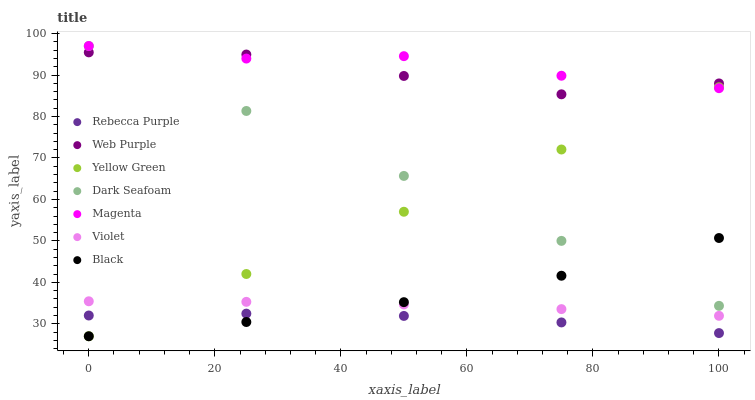Does Rebecca Purple have the minimum area under the curve?
Answer yes or no. Yes. Does Magenta have the maximum area under the curve?
Answer yes or no. Yes. Does Dark Seafoam have the minimum area under the curve?
Answer yes or no. No. Does Dark Seafoam have the maximum area under the curve?
Answer yes or no. No. Is Dark Seafoam the smoothest?
Answer yes or no. Yes. Is Web Purple the roughest?
Answer yes or no. Yes. Is Web Purple the smoothest?
Answer yes or no. No. Is Dark Seafoam the roughest?
Answer yes or no. No. Does Yellow Green have the lowest value?
Answer yes or no. Yes. Does Dark Seafoam have the lowest value?
Answer yes or no. No. Does Magenta have the highest value?
Answer yes or no. Yes. Does Web Purple have the highest value?
Answer yes or no. No. Is Violet less than Magenta?
Answer yes or no. Yes. Is Magenta greater than Black?
Answer yes or no. Yes. Does Dark Seafoam intersect Magenta?
Answer yes or no. Yes. Is Dark Seafoam less than Magenta?
Answer yes or no. No. Is Dark Seafoam greater than Magenta?
Answer yes or no. No. Does Violet intersect Magenta?
Answer yes or no. No. 